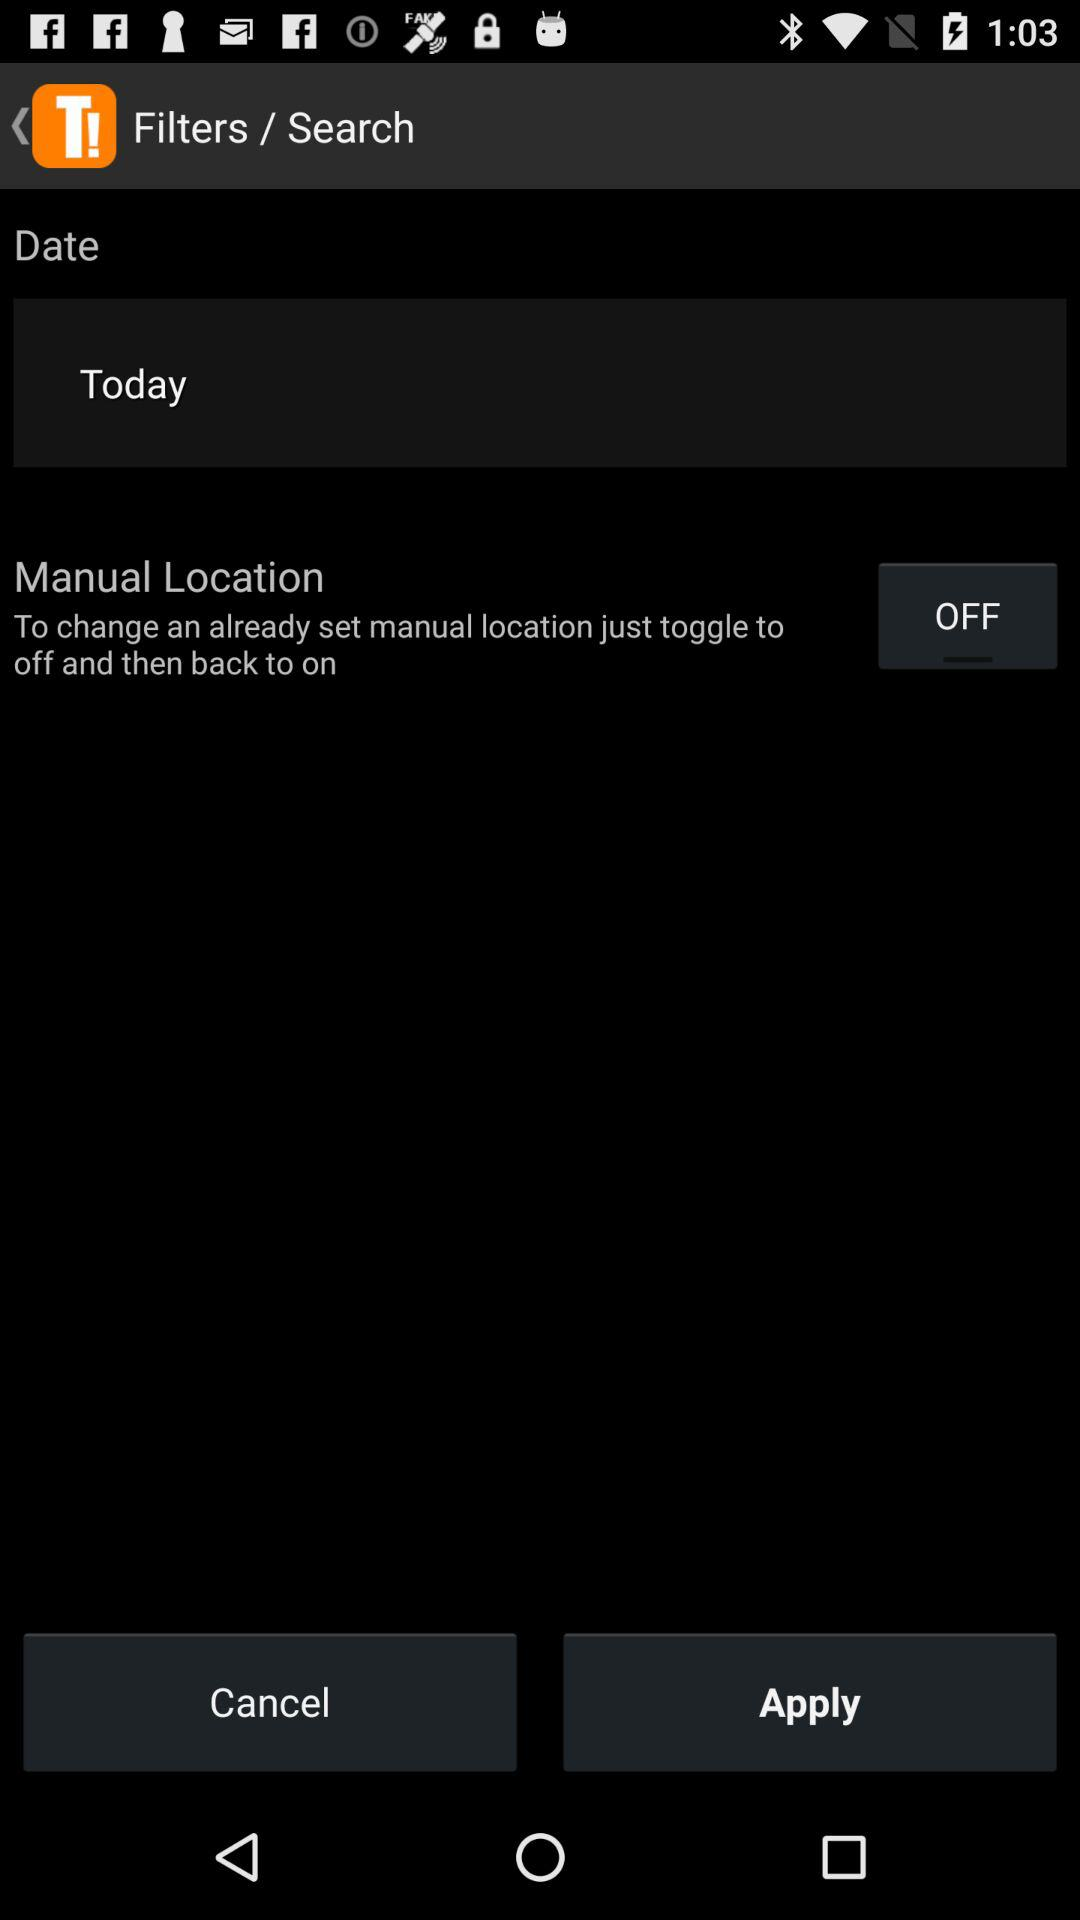What is the shown day? The day is today. 